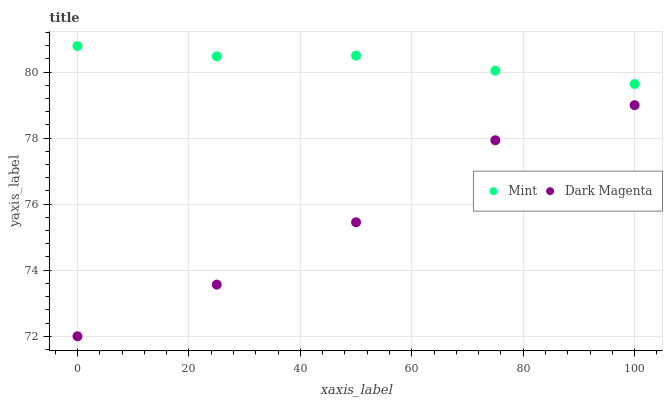Does Dark Magenta have the minimum area under the curve?
Answer yes or no. Yes. Does Mint have the maximum area under the curve?
Answer yes or no. Yes. Does Dark Magenta have the maximum area under the curve?
Answer yes or no. No. Is Mint the smoothest?
Answer yes or no. Yes. Is Dark Magenta the roughest?
Answer yes or no. Yes. Is Dark Magenta the smoothest?
Answer yes or no. No. Does Dark Magenta have the lowest value?
Answer yes or no. Yes. Does Mint have the highest value?
Answer yes or no. Yes. Does Dark Magenta have the highest value?
Answer yes or no. No. Is Dark Magenta less than Mint?
Answer yes or no. Yes. Is Mint greater than Dark Magenta?
Answer yes or no. Yes. Does Dark Magenta intersect Mint?
Answer yes or no. No. 